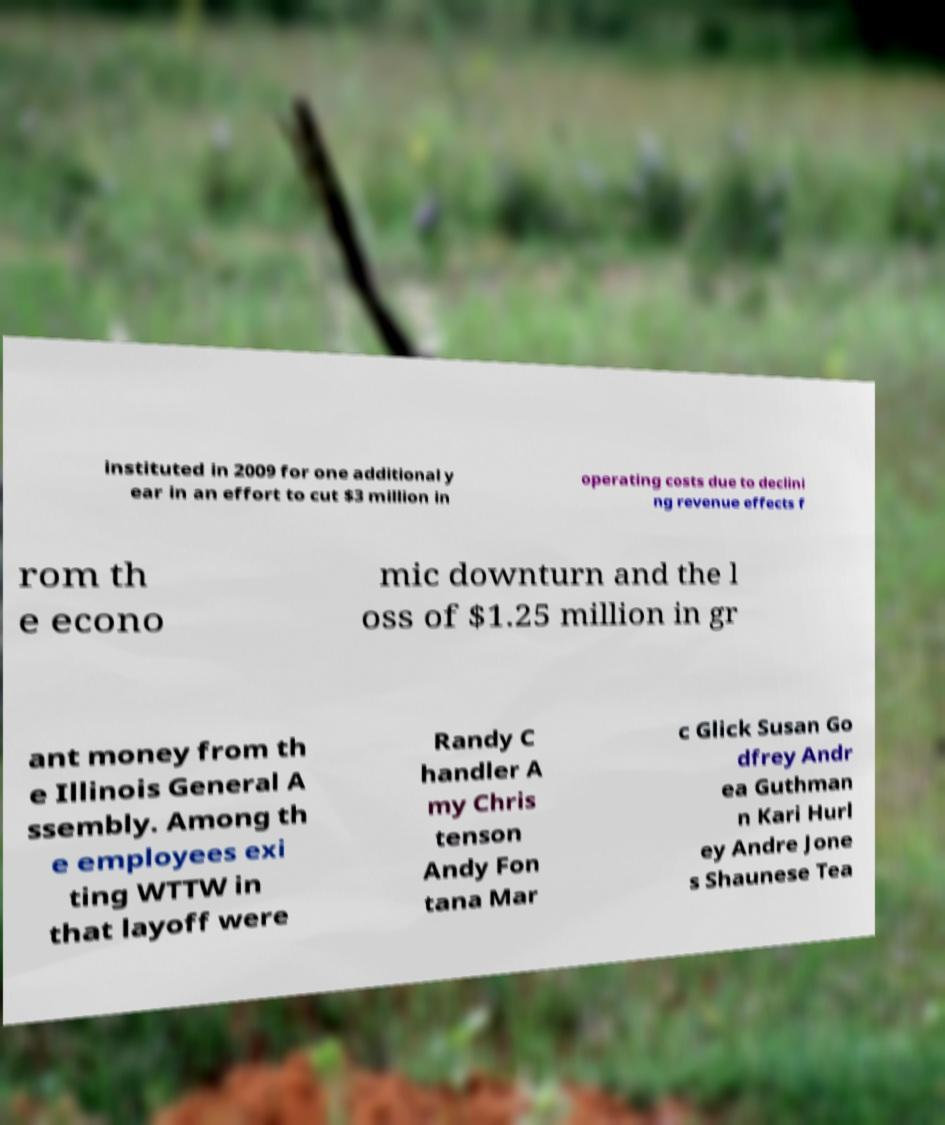Please read and relay the text visible in this image. What does it say? instituted in 2009 for one additional y ear in an effort to cut $3 million in operating costs due to declini ng revenue effects f rom th e econo mic downturn and the l oss of $1.25 million in gr ant money from th e Illinois General A ssembly. Among th e employees exi ting WTTW in that layoff were Randy C handler A my Chris tenson Andy Fon tana Mar c Glick Susan Go dfrey Andr ea Guthman n Kari Hurl ey Andre Jone s Shaunese Tea 